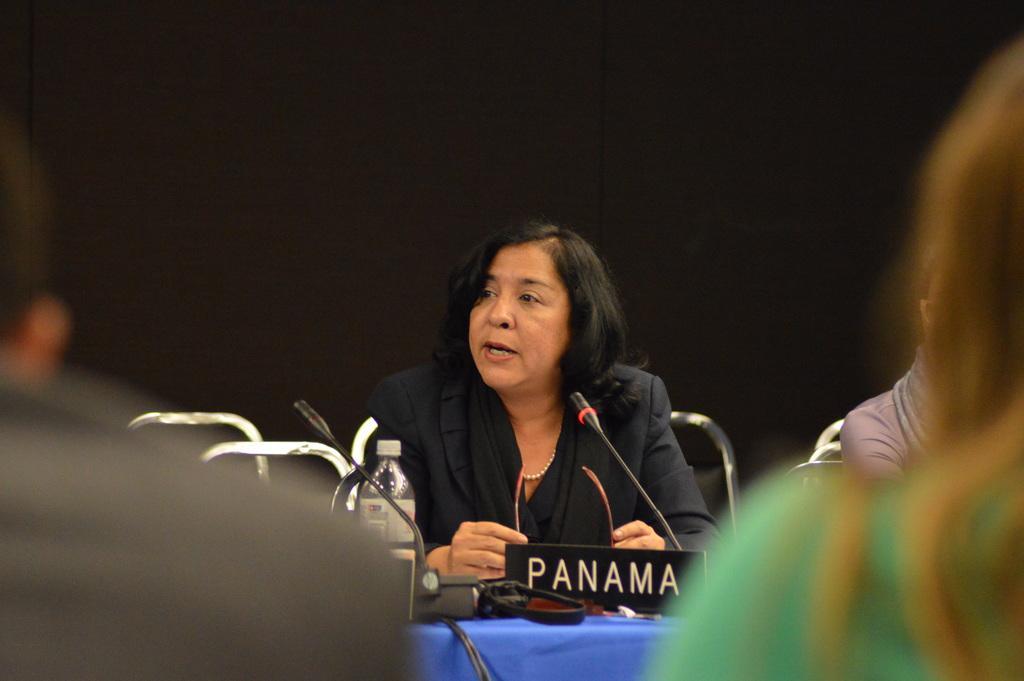Can you describe this image briefly? In this image there is a woman holding glasses in front of a mike and she is sitting on the chair, placing her hands on the table. There is a bottle, name board, black color object and blue color cloth on the table. Image also consists of three people and also chairs. 